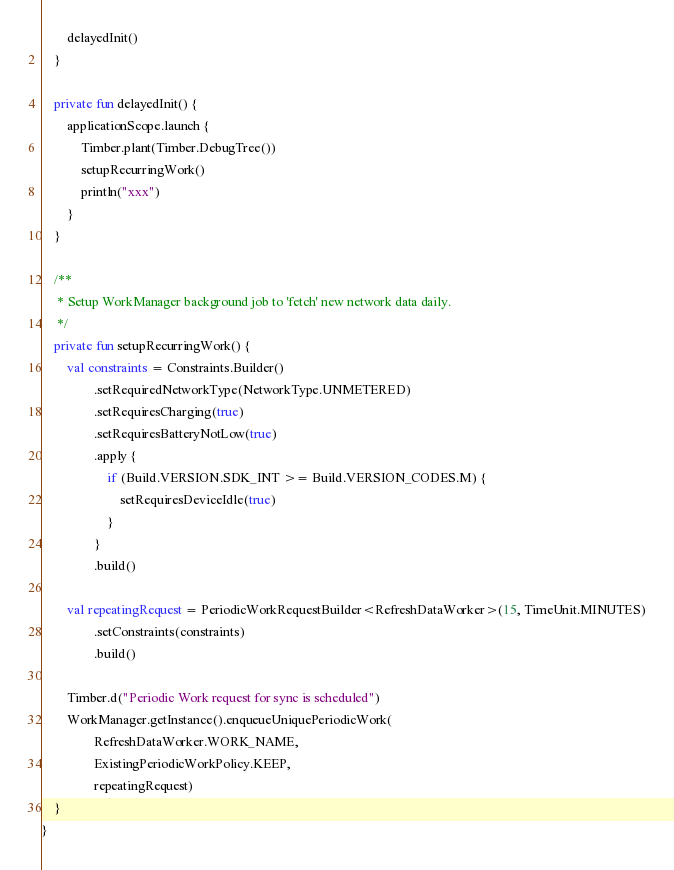Convert code to text. <code><loc_0><loc_0><loc_500><loc_500><_Kotlin_>        delayedInit()
    }

    private fun delayedInit() {
        applicationScope.launch {
            Timber.plant(Timber.DebugTree())
            setupRecurringWork()
            println("xxx")
        }
    }

    /**
     * Setup WorkManager background job to 'fetch' new network data daily.
     */
    private fun setupRecurringWork() {
        val constraints = Constraints.Builder()
                .setRequiredNetworkType(NetworkType.UNMETERED)
                .setRequiresCharging(true)
                .setRequiresBatteryNotLow(true)
                .apply {
                    if (Build.VERSION.SDK_INT >= Build.VERSION_CODES.M) {
                        setRequiresDeviceIdle(true)
                    }
                }
                .build()

        val repeatingRequest = PeriodicWorkRequestBuilder<RefreshDataWorker>(15, TimeUnit.MINUTES)
                .setConstraints(constraints)
                .build()

        Timber.d("Periodic Work request for sync is scheduled")
        WorkManager.getInstance().enqueueUniquePeriodicWork(
                RefreshDataWorker.WORK_NAME,
                ExistingPeriodicWorkPolicy.KEEP,
                repeatingRequest)
    }
}
</code> 